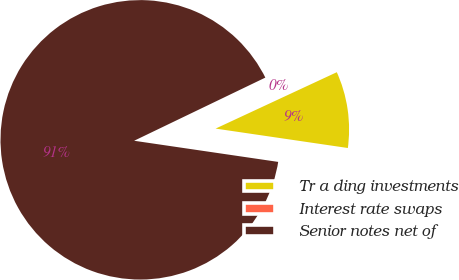<chart> <loc_0><loc_0><loc_500><loc_500><pie_chart><fcel>Tr a ding investments<fcel>Interest rate swaps<fcel>Senior notes net of<nl><fcel>9.25%<fcel>0.21%<fcel>90.54%<nl></chart> 